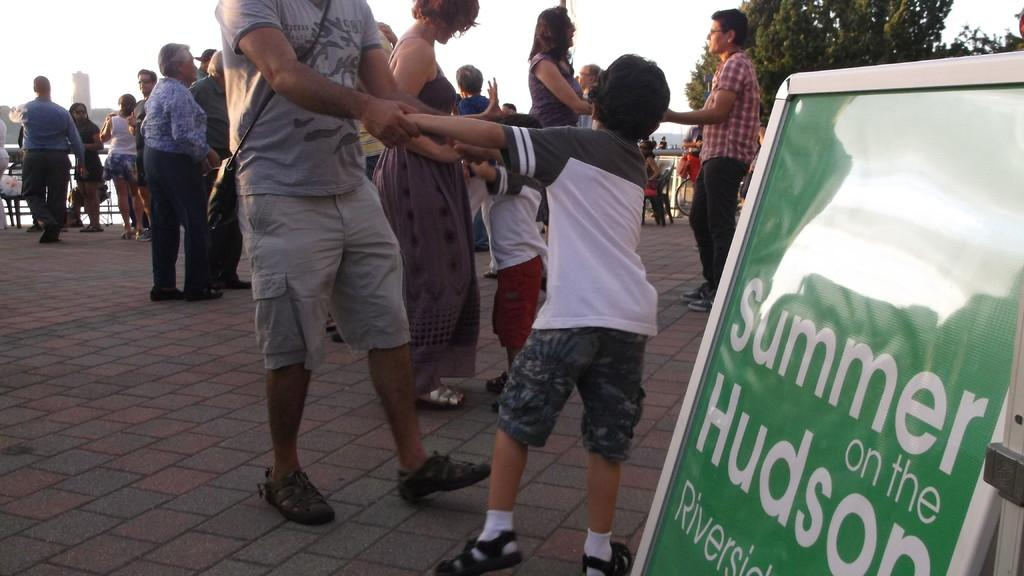What are the people in the image doing? There are persons standing on the floor and sitting on chairs in the image. What can be seen on the wall in the image? There is an information board in the image. What mode of transportation is present in the image? There is a bicycle in the image. What is visible in the background of the image? The sky and trees are visible in the image. What type of bread is being served for lunch in the image? There is no bread or lunch being served in the image; it only shows people standing, sitting, and a bicycle. 